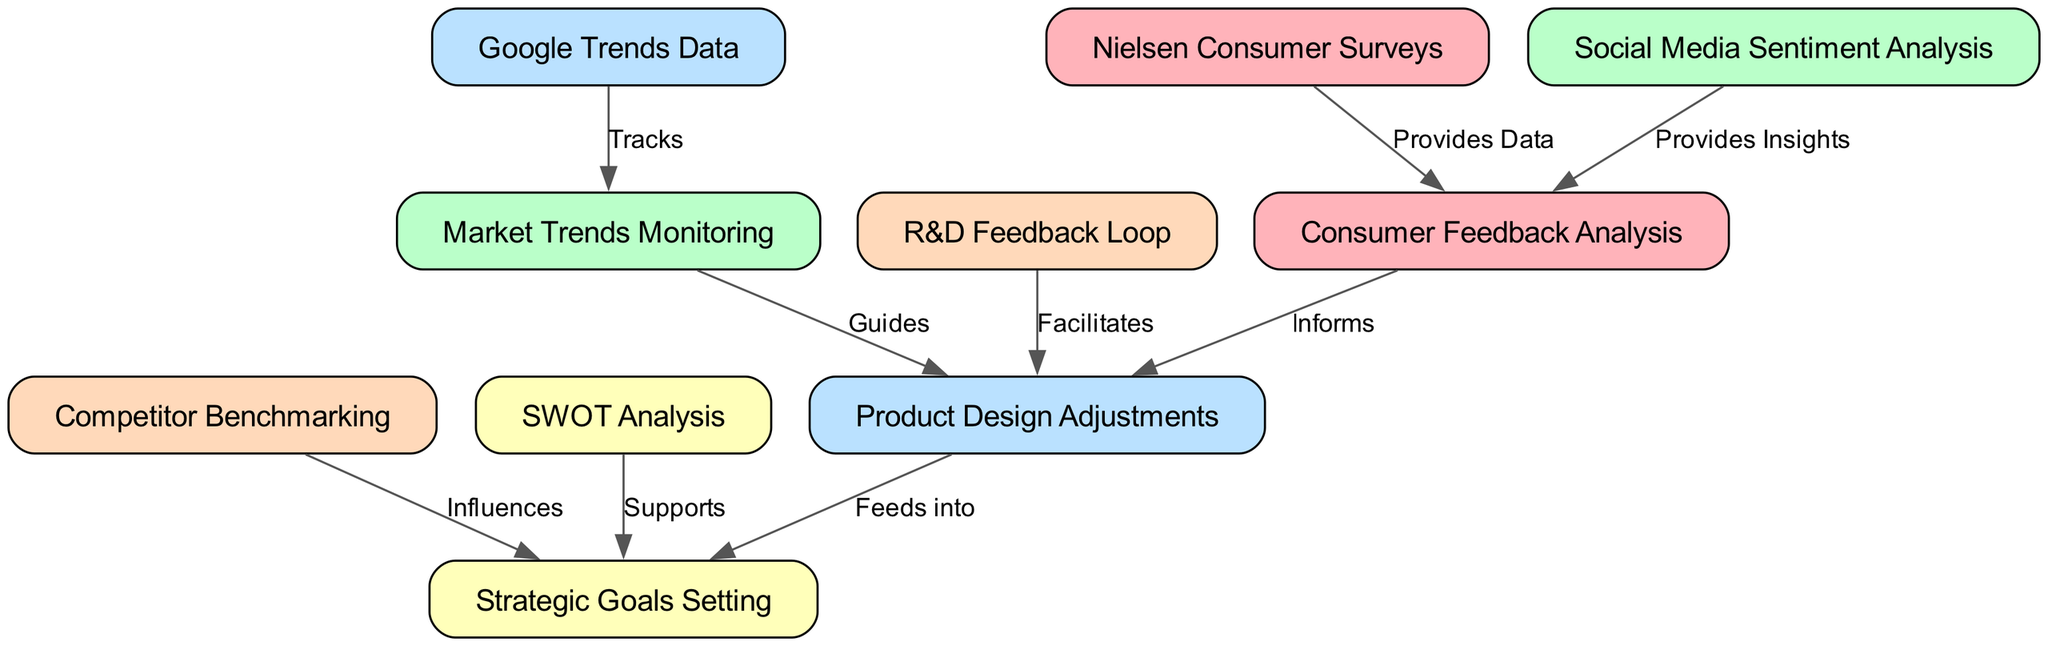What is the total number of nodes in the diagram? The diagram contains ten nodes, which can be counted directly in the list provided: Consumer Feedback Analysis, Market Trends Monitoring, Product Design Adjustments, Strategic Goals Setting, Competitor Benchmarking, Nielsen Consumer Surveys, Social Media Sentiment Analysis, Google Trends Data, SWOT Analysis, and R&D Feedback Loop.
Answer: 10 Which node provides insights to Consumer Feedback Analysis? Social Media Sentiment Analysis directly connects to Consumer Feedback Analysis with the label "Provides Insights," indicating that this node shares valuable information.
Answer: Social Media Sentiment Analysis How many edges are connected to the Product Design Adjustments node? Product Design Adjustments has three outgoing edges, connecting to Strategic Goals Setting, Consumer Feedback Analysis, and R&D Feedback Loop, as identified in the edges list.
Answer: 3 What influences the setting of Strategic Goals? The diagram shows two nodes influencing Strategic Goals Setting: Competitor Benchmarking and SWOT Analysis, as indicated by the edges connecting these nodes to Strategic Goals Setting with the labels "Influences" and "Supports."
Answer: Competitor Benchmarking, SWOT Analysis What data does Nielsen Consumer Surveys provide? The connection from Nielsen Consumer Surveys to Consumer Feedback Analysis indicates that Nielsen Consumer Surveys "Provides Data" that informs the feedback analysis process within the diagram.
Answer: Data Which node tracks market trends? Google Trends Data connects to Market Trends Monitoring with the label "Tracks," indicating that this node is responsible for tracking the relevant trends in the market.
Answer: Google Trends Data How many methods inform Product Design Adjustments? Product Design Adjustments is informed by two nodes: Consumer Feedback Analysis and Market Trends Monitoring, as reflected in the edges labeled "Informs" and "Guides."
Answer: 2 What facilitates Product Design Adjustments? The R&D Feedback Loop node is connected to Product Design Adjustments with the label "Facilitates," showing that it plays a supportive role in the design adjustment process.
Answer: R&D Feedback Loop Which analysis supports Strategic Goals Setting? SWOT Analysis is designated as supporting Strategic Goals Setting in the diagram, as indicated by the edge labeled "Supports" connecting these two nodes.
Answer: SWOT Analysis 